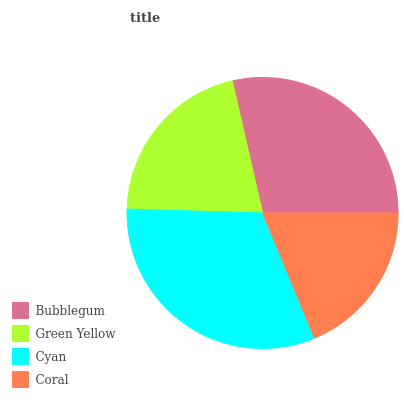Is Coral the minimum?
Answer yes or no. Yes. Is Cyan the maximum?
Answer yes or no. Yes. Is Green Yellow the minimum?
Answer yes or no. No. Is Green Yellow the maximum?
Answer yes or no. No. Is Bubblegum greater than Green Yellow?
Answer yes or no. Yes. Is Green Yellow less than Bubblegum?
Answer yes or no. Yes. Is Green Yellow greater than Bubblegum?
Answer yes or no. No. Is Bubblegum less than Green Yellow?
Answer yes or no. No. Is Bubblegum the high median?
Answer yes or no. Yes. Is Green Yellow the low median?
Answer yes or no. Yes. Is Coral the high median?
Answer yes or no. No. Is Coral the low median?
Answer yes or no. No. 